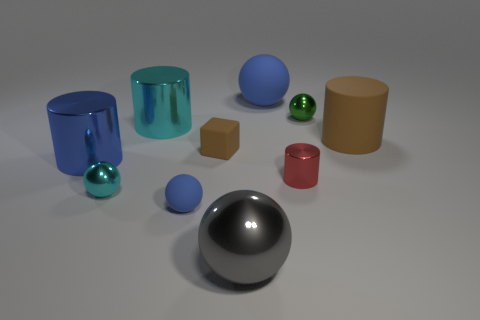There is a metal cylinder that is in front of the blue metal cylinder; is it the same color as the small matte block? no 